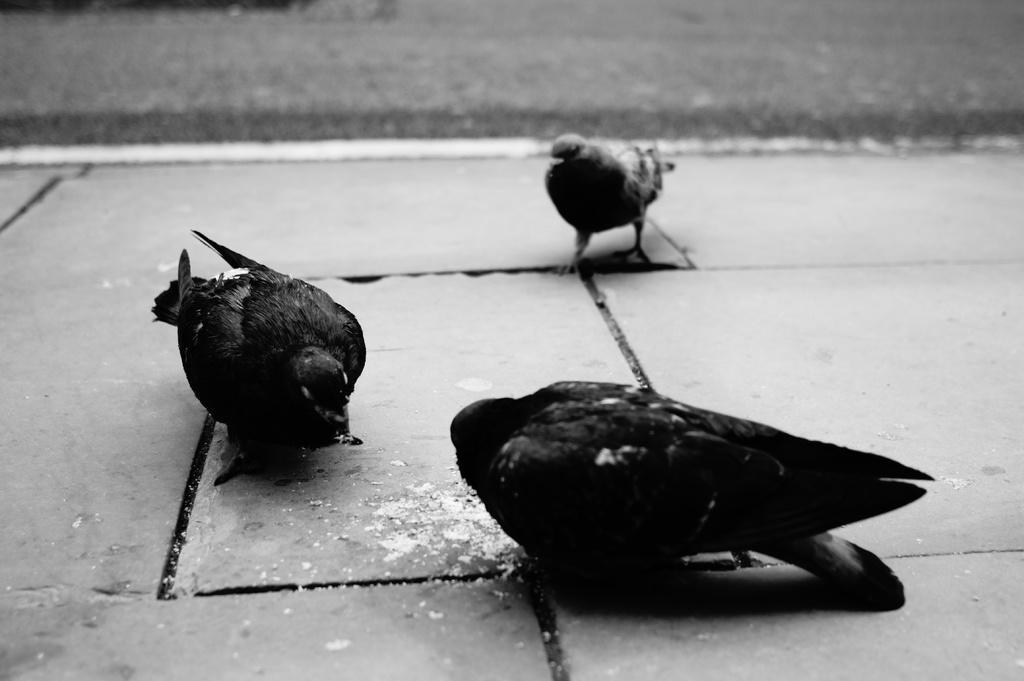Please provide a concise description of this image. In this image I can see few birds which are black and ash in color on the side walk. In the background I can see the road. 